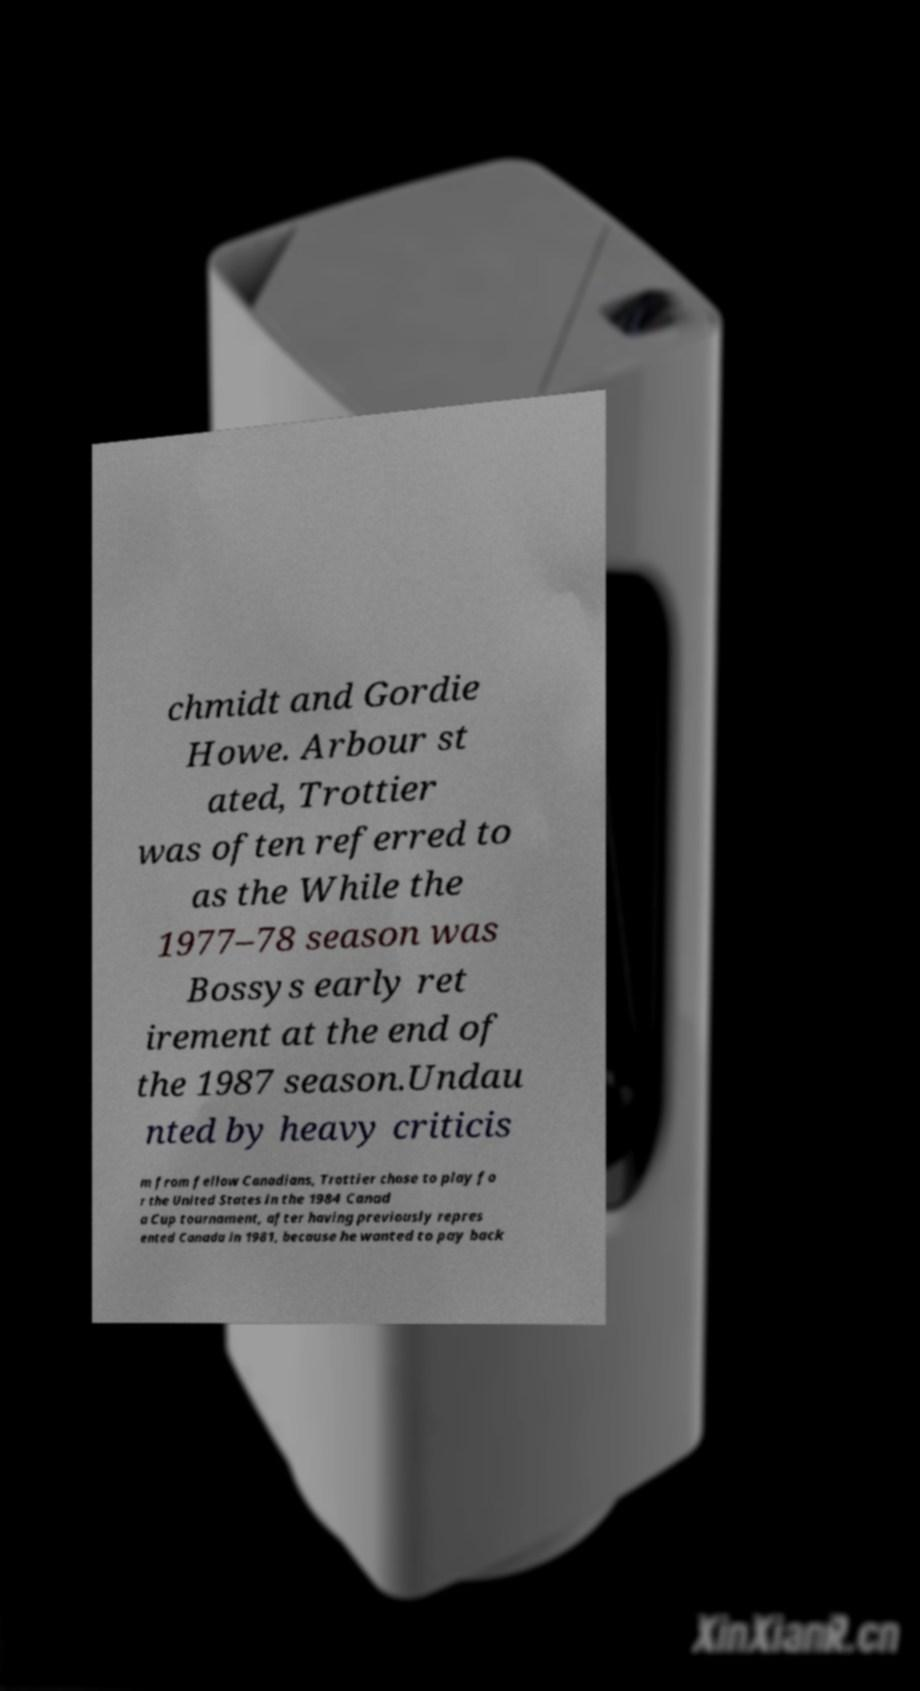Could you extract and type out the text from this image? chmidt and Gordie Howe. Arbour st ated, Trottier was often referred to as the While the 1977–78 season was Bossys early ret irement at the end of the 1987 season.Undau nted by heavy criticis m from fellow Canadians, Trottier chose to play fo r the United States in the 1984 Canad a Cup tournament, after having previously repres ented Canada in 1981, because he wanted to pay back 